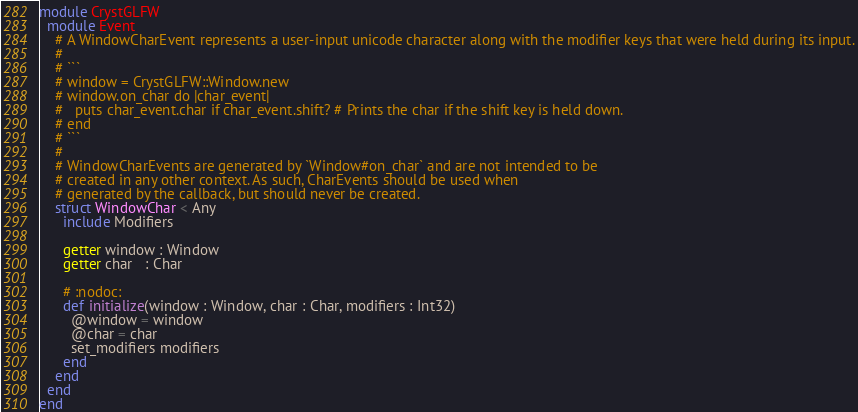<code> <loc_0><loc_0><loc_500><loc_500><_Crystal_>module CrystGLFW
  module Event
    # A WindowCharEvent represents a user-input unicode character along with the modifier keys that were held during its input.
    #
    # ```
    # window = CrystGLFW::Window.new
    # window.on_char do |char_event|
    #   puts char_event.char if char_event.shift? # Prints the char if the shift key is held down.
    # end
    # ```
    #
    # WindowCharEvents are generated by `Window#on_char` and are not intended to be
    # created in any other context. As such, CharEvents should be used when
    # generated by the callback, but should never be created.
    struct WindowChar < Any
      include Modifiers

      getter window : Window
      getter char   : Char

      # :nodoc:
      def initialize(window : Window, char : Char, modifiers : Int32)
        @window = window
        @char = char
        set_modifiers modifiers
      end
    end
  end
end
</code> 